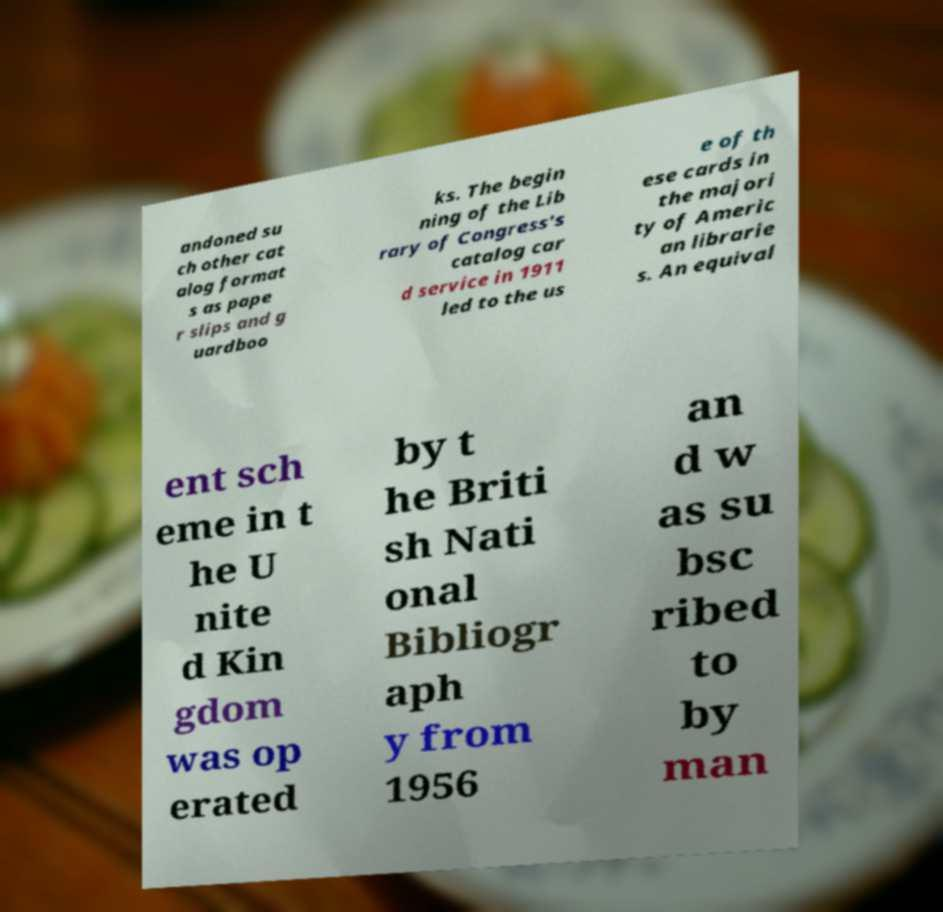I need the written content from this picture converted into text. Can you do that? andoned su ch other cat alog format s as pape r slips and g uardboo ks. The begin ning of the Lib rary of Congress's catalog car d service in 1911 led to the us e of th ese cards in the majori ty of Americ an librarie s. An equival ent sch eme in t he U nite d Kin gdom was op erated by t he Briti sh Nati onal Bibliogr aph y from 1956 an d w as su bsc ribed to by man 